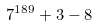Convert formula to latex. <formula><loc_0><loc_0><loc_500><loc_500>7 ^ { 1 8 9 } + 3 - 8</formula> 